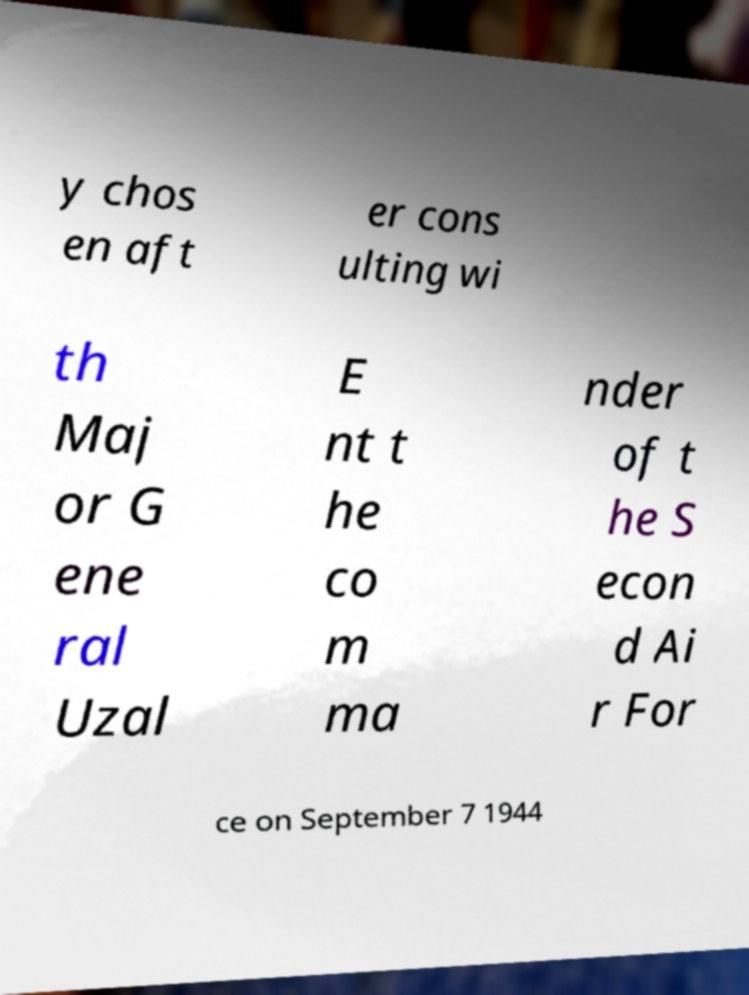Please read and relay the text visible in this image. What does it say? y chos en aft er cons ulting wi th Maj or G ene ral Uzal E nt t he co m ma nder of t he S econ d Ai r For ce on September 7 1944 